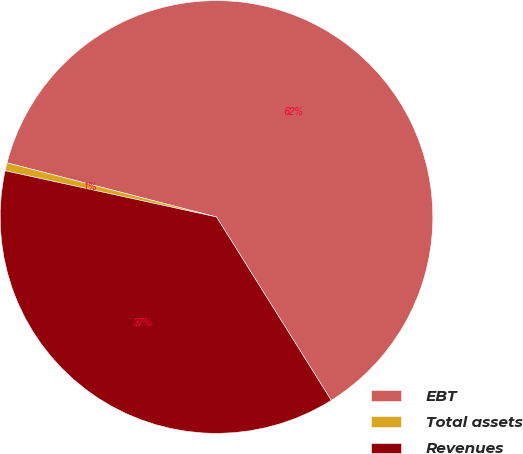<chart> <loc_0><loc_0><loc_500><loc_500><pie_chart><fcel>EBT<fcel>Total assets<fcel>Revenues<nl><fcel>62.08%<fcel>0.6%<fcel>37.33%<nl></chart> 